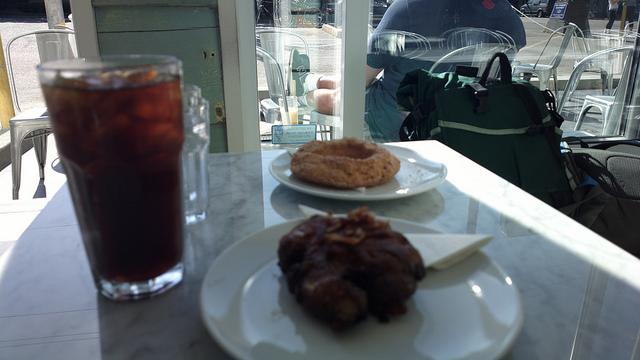What kinds of food is on the table?
Keep it brief. Donuts. In container is something that will melt in time?
Short answer required. Yes. Is this an outdoor eating area?
Write a very short answer. No. 